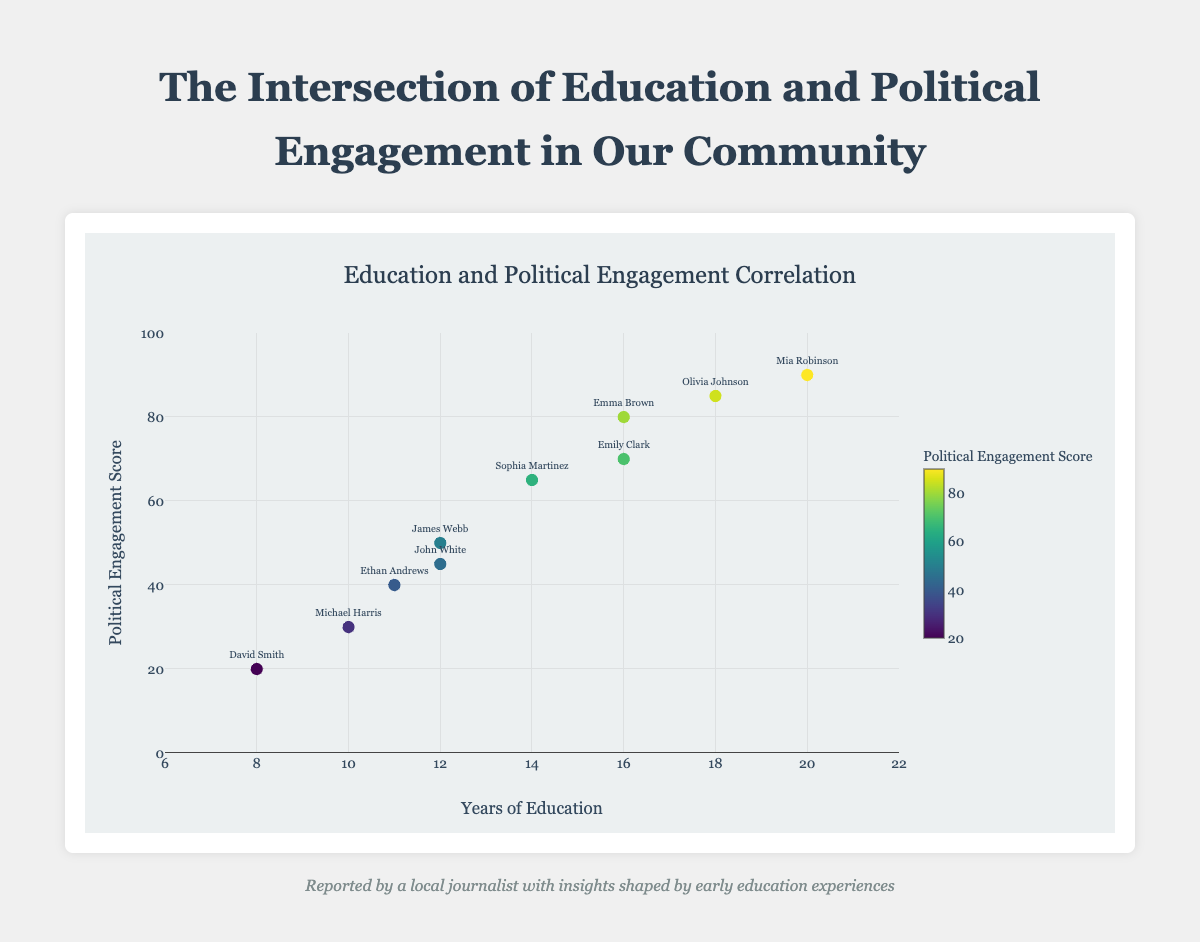What's the title of the chart? The title is written at the top of the chart and it reads "Education and Political Engagement Correlation".
Answer: Education and Political Engagement Correlation How many data points are plotted on the scatter plot? By counting the number of markers representing individuals on the scatter plot, we find there are 10 data points.
Answer: 10 Who has the highest political engagement score and how many years of education do they have? By looking at the top-most point on the y-axis (political engagement score), we see that Mia Robinson has the highest score with a political engagement score of 90 and 20 years of education.
Answer: Mia Robinson, 20 years What is the political engagement score of someone with 12 years of education? There are two points corresponding to 12 years of education on the x-axis. By checking their y-axis values, John White has a score of 45 and James Webb has a score of 50.
Answer: 45, 50 On average, how many years of education do people with a political engagement score greater than or equal to 80 have? The people with a political engagement score of 80 or more are Emma Brown (16 years), Olivia Johnson (18 years), and Mia Robinson (20 years). Summing these and dividing by 3 gives an average: (16 + 18 + 20) / 3 = 18 years.
Answer: 18 years Is there a positive or negative trend between years of education and political engagement score? Observing the general direction of the data points, as the years of education increases, the political engagement scores also tend to increase, indicating a positive trend.
Answer: Positive Who has the lowest political engagement score and how many years of education do they have? Looking at the bottom-most data point on the y-axis, David Smith has the lowest score of 20 with 8 years of education.
Answer: David Smith, 8 years What is the color of the marker for the highest political engagement score? The highest political engagement score (90) corresponds to Mia Robinson. Her marker's color is found at the yellow end of the "Viridis" colorscale.
Answer: Yellow Which individual with more than 10 years of education has the least political engagement score? Checking the individuals with more than 10 years of education, Ethan Andrews has 11 years of education and a score of 40, while John White and James Webb have 12 years of education and scores of 45 and 50 respectively. Ethan Andrews has the least score among these.
Answer: Ethan Andrews 